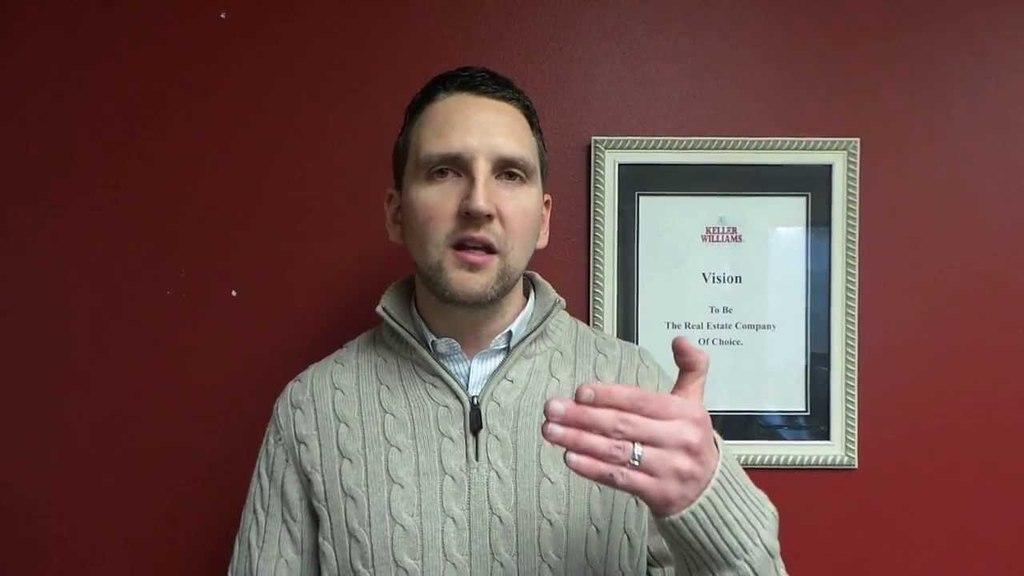What is the main subject of the image? There is a man standing in the center of the image. What is the man doing in the image? The man is talking in the image. What can be seen in the background of the image? There is a wall frame in the background of the image. How many pies can be seen on the man's muscles in the image? There are no pies visible on the man's muscles in the image, as the facts provided do not mention any pies or muscles. 